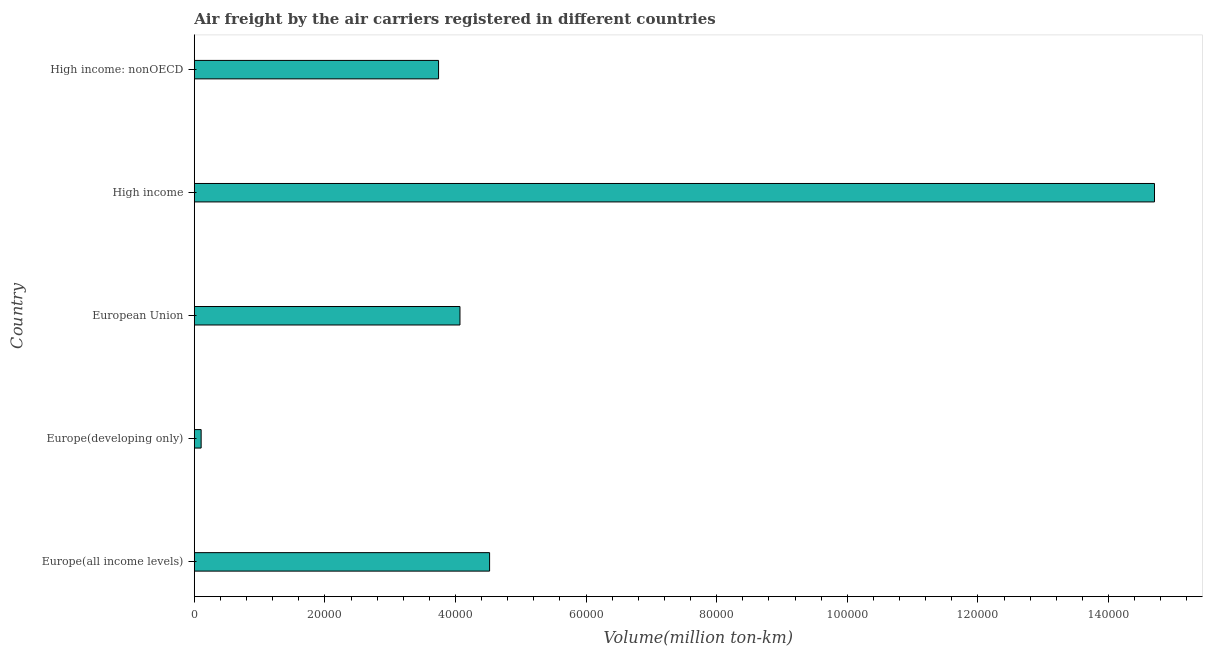Does the graph contain any zero values?
Offer a very short reply. No. What is the title of the graph?
Your response must be concise. Air freight by the air carriers registered in different countries. What is the label or title of the X-axis?
Offer a terse response. Volume(million ton-km). What is the label or title of the Y-axis?
Provide a short and direct response. Country. What is the air freight in High income: nonOECD?
Provide a succinct answer. 3.74e+04. Across all countries, what is the maximum air freight?
Keep it short and to the point. 1.47e+05. Across all countries, what is the minimum air freight?
Offer a terse response. 1052.31. In which country was the air freight maximum?
Keep it short and to the point. High income. In which country was the air freight minimum?
Provide a short and direct response. Europe(developing only). What is the sum of the air freight?
Your answer should be very brief. 2.71e+05. What is the difference between the air freight in Europe(all income levels) and High income?
Your answer should be compact. -1.02e+05. What is the average air freight per country?
Offer a very short reply. 5.43e+04. What is the median air freight?
Offer a very short reply. 4.07e+04. What is the ratio of the air freight in Europe(developing only) to that in European Union?
Your answer should be compact. 0.03. Is the difference between the air freight in Europe(all income levels) and Europe(developing only) greater than the difference between any two countries?
Your answer should be compact. No. What is the difference between the highest and the second highest air freight?
Your response must be concise. 1.02e+05. Is the sum of the air freight in Europe(all income levels) and High income greater than the maximum air freight across all countries?
Make the answer very short. Yes. What is the difference between the highest and the lowest air freight?
Ensure brevity in your answer.  1.46e+05. In how many countries, is the air freight greater than the average air freight taken over all countries?
Make the answer very short. 1. Are all the bars in the graph horizontal?
Make the answer very short. Yes. What is the difference between two consecutive major ticks on the X-axis?
Your answer should be compact. 2.00e+04. Are the values on the major ticks of X-axis written in scientific E-notation?
Make the answer very short. No. What is the Volume(million ton-km) of Europe(all income levels)?
Your answer should be very brief. 4.52e+04. What is the Volume(million ton-km) of Europe(developing only)?
Your response must be concise. 1052.31. What is the Volume(million ton-km) in European Union?
Give a very brief answer. 4.07e+04. What is the Volume(million ton-km) of High income?
Provide a short and direct response. 1.47e+05. What is the Volume(million ton-km) in High income: nonOECD?
Give a very brief answer. 3.74e+04. What is the difference between the Volume(million ton-km) in Europe(all income levels) and Europe(developing only)?
Your answer should be very brief. 4.42e+04. What is the difference between the Volume(million ton-km) in Europe(all income levels) and European Union?
Make the answer very short. 4536.45. What is the difference between the Volume(million ton-km) in Europe(all income levels) and High income?
Provide a succinct answer. -1.02e+05. What is the difference between the Volume(million ton-km) in Europe(all income levels) and High income: nonOECD?
Keep it short and to the point. 7816.09. What is the difference between the Volume(million ton-km) in Europe(developing only) and European Union?
Provide a short and direct response. -3.96e+04. What is the difference between the Volume(million ton-km) in Europe(developing only) and High income?
Make the answer very short. -1.46e+05. What is the difference between the Volume(million ton-km) in Europe(developing only) and High income: nonOECD?
Keep it short and to the point. -3.64e+04. What is the difference between the Volume(million ton-km) in European Union and High income?
Your response must be concise. -1.06e+05. What is the difference between the Volume(million ton-km) in European Union and High income: nonOECD?
Offer a very short reply. 3279.64. What is the difference between the Volume(million ton-km) in High income and High income: nonOECD?
Your answer should be compact. 1.10e+05. What is the ratio of the Volume(million ton-km) in Europe(all income levels) to that in Europe(developing only)?
Make the answer very short. 42.97. What is the ratio of the Volume(million ton-km) in Europe(all income levels) to that in European Union?
Offer a terse response. 1.11. What is the ratio of the Volume(million ton-km) in Europe(all income levels) to that in High income?
Offer a very short reply. 0.31. What is the ratio of the Volume(million ton-km) in Europe(all income levels) to that in High income: nonOECD?
Provide a short and direct response. 1.21. What is the ratio of the Volume(million ton-km) in Europe(developing only) to that in European Union?
Give a very brief answer. 0.03. What is the ratio of the Volume(million ton-km) in Europe(developing only) to that in High income?
Ensure brevity in your answer.  0.01. What is the ratio of the Volume(million ton-km) in Europe(developing only) to that in High income: nonOECD?
Give a very brief answer. 0.03. What is the ratio of the Volume(million ton-km) in European Union to that in High income?
Keep it short and to the point. 0.28. What is the ratio of the Volume(million ton-km) in European Union to that in High income: nonOECD?
Offer a very short reply. 1.09. What is the ratio of the Volume(million ton-km) in High income to that in High income: nonOECD?
Give a very brief answer. 3.93. 